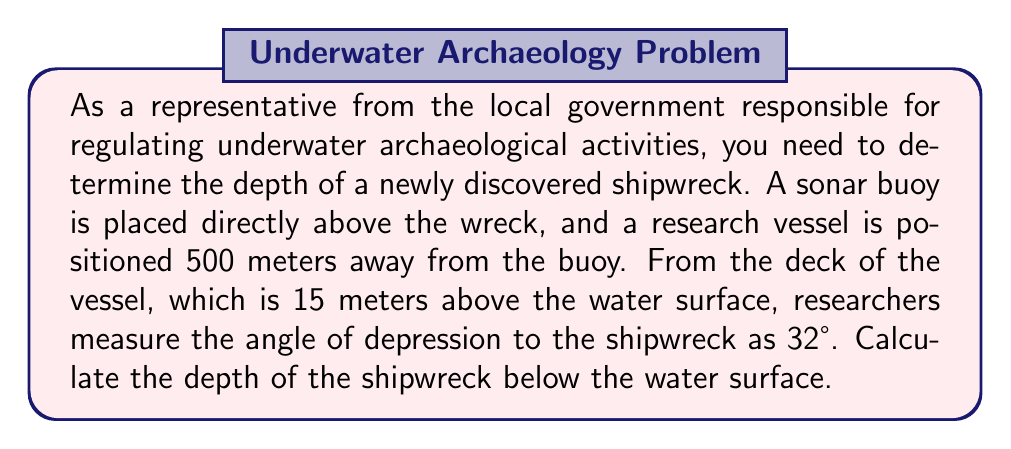Help me with this question. To solve this problem, we'll use trigonometric functions and the given information to create a right triangle. Let's break it down step by step:

1) First, let's visualize the scenario:

[asy]
import geometry;

size(200);
pair A = (0,0);
pair B = (5,0);
pair C = (0,3);
pair D = (0,3.15);

draw(A--B--C--A);
draw(D--C,dashed);

label("Water surface", (2.5,0), S);
label("500 m", (2.5,0), N);
label("Shipwreck", A, SW);
label("Buoy", C, E);
label("Vessel", B, E);
label("15 m", (5,1.5), E);
label("32°", (4.7,0.3), NE);
label("x", (0,1.5), W);

dot(A);
dot(B);
dot(C);
dot(D);
[/asy]

2) Let's define our variables:
   - Let $x$ be the depth of the shipwreck below the water surface
   - The horizontal distance from the vessel to the buoy is 500 meters
   - The height of the vessel's deck above water is 15 meters

3) We can see that we have a right triangle. The angle of depression is 32°, which is the same as the angle formed at the vessel in our triangle.

4) In this triangle:
   - The adjacent side to our angle is 500 meters
   - The opposite side is $(x + 15)$ meters (depth plus vessel height)

5) We can use the tangent function to set up our equation:

   $$\tan(32°) = \frac{\text{opposite}}{\text{adjacent}} = \frac{x + 15}{500}$$

6) Now, let's solve for $x$:

   $$\begin{align}
   \tan(32°) &= \frac{x + 15}{500} \\
   500 \cdot \tan(32°) &= x + 15 \\
   500 \cdot \tan(32°) - 15 &= x
   \end{align}$$

7) Calculate the result:
   $$\begin{align}
   x &= 500 \cdot \tan(32°) - 15 \\
   &\approx 500 \cdot 0.6249 - 15 \\
   &\approx 312.45 - 15 \\
   &\approx 297.45 \text{ meters}
   \end{align}$$

Therefore, the depth of the shipwreck below the water surface is approximately 297.45 meters.
Answer: The depth of the shipwreck is approximately 297.45 meters below the water surface. 